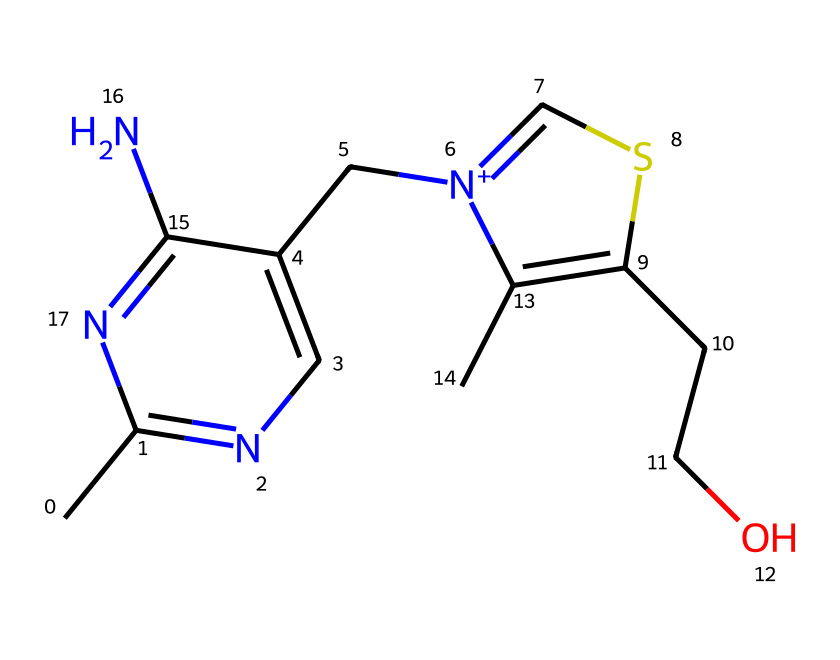What is the molecular formula of thiamine? The molecular formula can be derived from the arrangement of atoms in the chemical structure. By counting the number of different atom types in the SMILES representation, we find there are carbon (C), nitrogen (N), sulfur (S), and oxygen (O) atoms that make up the whole molecule, resulting in a formula of C12H17N4OS.
Answer: C12H17N4OS How many nitrogen atoms are present in thiamine? In the SMILES representation, nitrogen atoms are indicated by the letter 'N'. Counting these in the structure shows that there are four nitrogen atoms.
Answer: 4 What is the significance of sulfur in thiamine? Thiamine contains a sulfur atom, which is characteristic of organosulfur compounds and is crucial for its biological function. The presence of sulfur is important for the stability and function of thiamine in biochemical processes.
Answer: biological function Is thiamine classified as a vitamin? Thiamine, also known as vitamin B1, is classified as a vitamin because it is an essential nutrient for human metabolism, particularly in energy production from carbohydrates.
Answer: yes What type of bonds are present in thiamine? In thiamine, there are both covalent bonds (between C and N atoms, as well as C and O atoms) and ionic bonds (due to the positively charged nitrogen). This combination allows for the stability and reactivity of the molecule.
Answer: covalent and ionic How many rings are in the molecular structure of thiamine? The chemical structure of thiamine includes two fused rings present in the bicyclic part of the molecule. This characteristic is important for its stability and interaction in biological systems.
Answer: 2 What role does thiamine play for truck drivers? Thiamine plays a crucial role in converting carbohydrates into energy; this is essential for truck drivers who require sustained energy for long hours on the road. Its importance is amplified in energy drinks that target drivers for enhanced performance.
Answer: energy production 